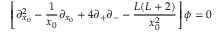<formula> <loc_0><loc_0><loc_500><loc_500>\left [ \partial _ { x _ { 0 } } ^ { 2 } - \frac { 1 } { x _ { 0 } } \partial _ { x _ { 0 } } + 4 \partial _ { + } \partial _ { - } - \frac { L ( L + 2 ) } { x _ { 0 } ^ { 2 } } \right ] \phi = 0</formula> 